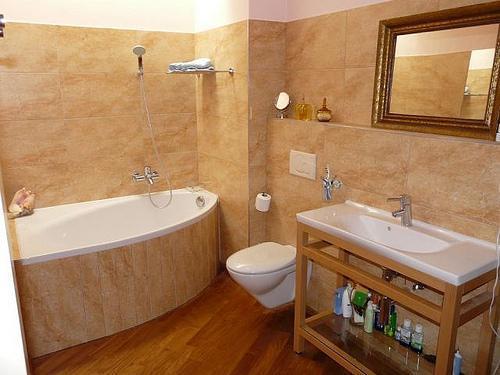How many sinks?
Give a very brief answer. 1. 